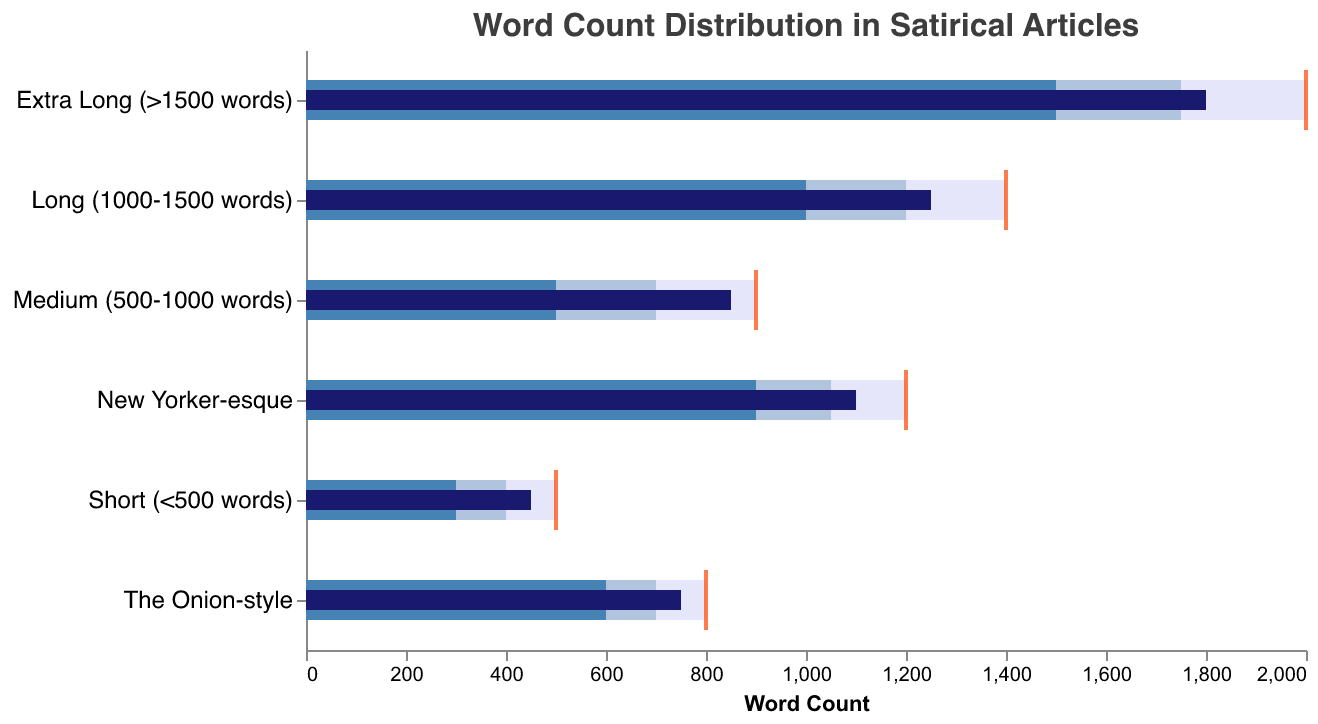What is the actual word count for "Short (<500 words)" articles? The actual word count for "Short (<500 words)" is represented by the darkest bar, which corresponds to a value of 450.
Answer: 450 What is the target word count for "New Yorker-esque" articles? The target word count is indicated by the orange tick mark. For "New Yorker-esque" articles, this mark is at 1200.
Answer: 1200 Which category has the highest actual word count? The highest actual word count is represented by the longest dark bar. The category with the highest value is "Extra Long (>1500 words)" at 1800 words.
Answer: Extra Long (>1500 words) How far off is the actual word count from the target for "Medium (500-1000 words)" articles? The actual word count is 850 and the target is 900. The difference is 900 - 850 = 50 words.
Answer: 50 words Which category has an actual word count closer to its target, "The Onion-style" or "New Yorker-esque"? For "The Onion-style," the actual is 750 and the target is 800, a difference of 50. For "New Yorker-esque," the actual is 1100 and the target is 1200, a difference of 100. So, "The Onion-style" is closer.
Answer: The Onion-style In which range does the actual word count for "Long (1000-1500 words)" articles fall? The actual word count for "Long (1000-1500 words)" articles is 1250. It falls within the second range (1000-1200 words) but below the third range's maximum (1400 words).
Answer: Second range (1000-1200 words) Is there any category where the actual word count exceeds the target word count? By observing the position of the dark bars relative to the orange tick marks, no category exceeds its target as the dark bars are shorter than or equal to the tick marks.
Answer: No Which category has the smallest difference between the highest range value and its target? "Shortest" refers to the difference between the highest range value and the target. For "Short (<500 words)" it's 500-500=0, for "Medium (500-1000 words)" it's 900-900=0, for "Long (1000-1500 words)" it's 1400-1400=0, "Extra Long (>1500 words)" it's 2000-2000=0, "The Onion-style" it's 800-800=0, and "New Yorker-esque" it's 1200-1200=0. All categories have the same smallest difference of 0.
Answer: No difference for all categories Which category has the widest range for high performance? The range for high performance is indicated by the lightest shaded bar. "Extra Long (>1500 words)" has a range from 1500 to 2000, which is a span of 500 words. This is the widest.
Answer: Extra Long (>1500 words) 